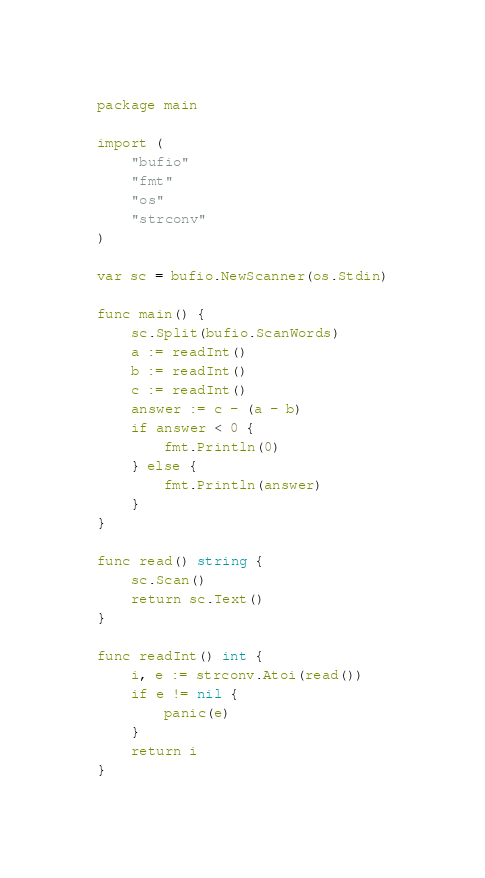<code> <loc_0><loc_0><loc_500><loc_500><_Go_>package main

import (
	"bufio"
	"fmt"
	"os"
	"strconv"
)

var sc = bufio.NewScanner(os.Stdin)

func main() {
	sc.Split(bufio.ScanWords)
	a := readInt()
	b := readInt()
	c := readInt()
	answer := c - (a - b)
	if answer < 0 {
		fmt.Println(0)
	} else {
		fmt.Println(answer)
	}
}

func read() string {
	sc.Scan()
	return sc.Text()
}

func readInt() int {
	i, e := strconv.Atoi(read())
	if e != nil {
		panic(e)
	}
	return i
}
</code> 